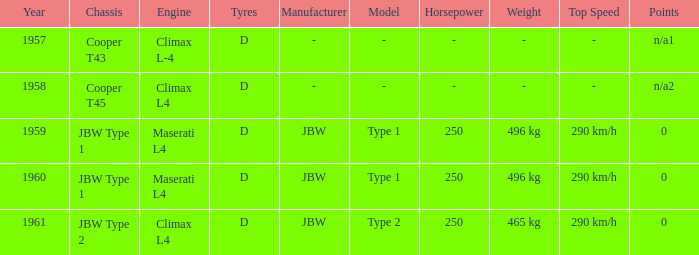What engine was for the vehicle with a cooper t43 chassis? Climax L-4. 